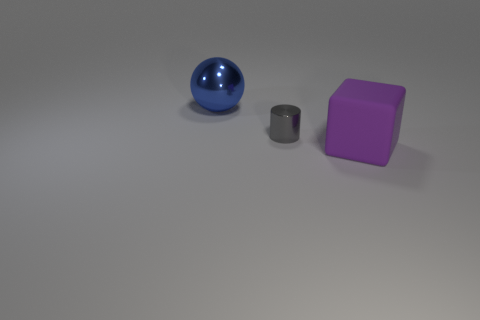What time of day does the lighting in the scene suggest? The scene has a dimly lit ambiance with soft shadows, which might suggest indoor artificial lighting, typically used during evening or night time, or possibly a controlled studio lighting setup. 